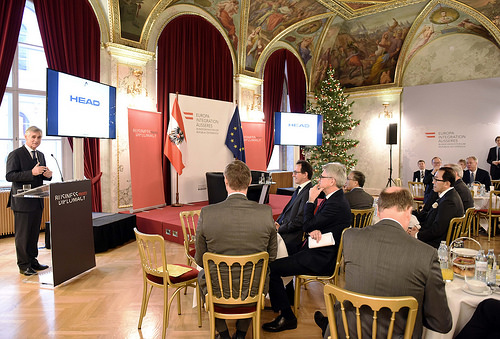<image>
Is there a chair above the floor? No. The chair is not positioned above the floor. The vertical arrangement shows a different relationship. 